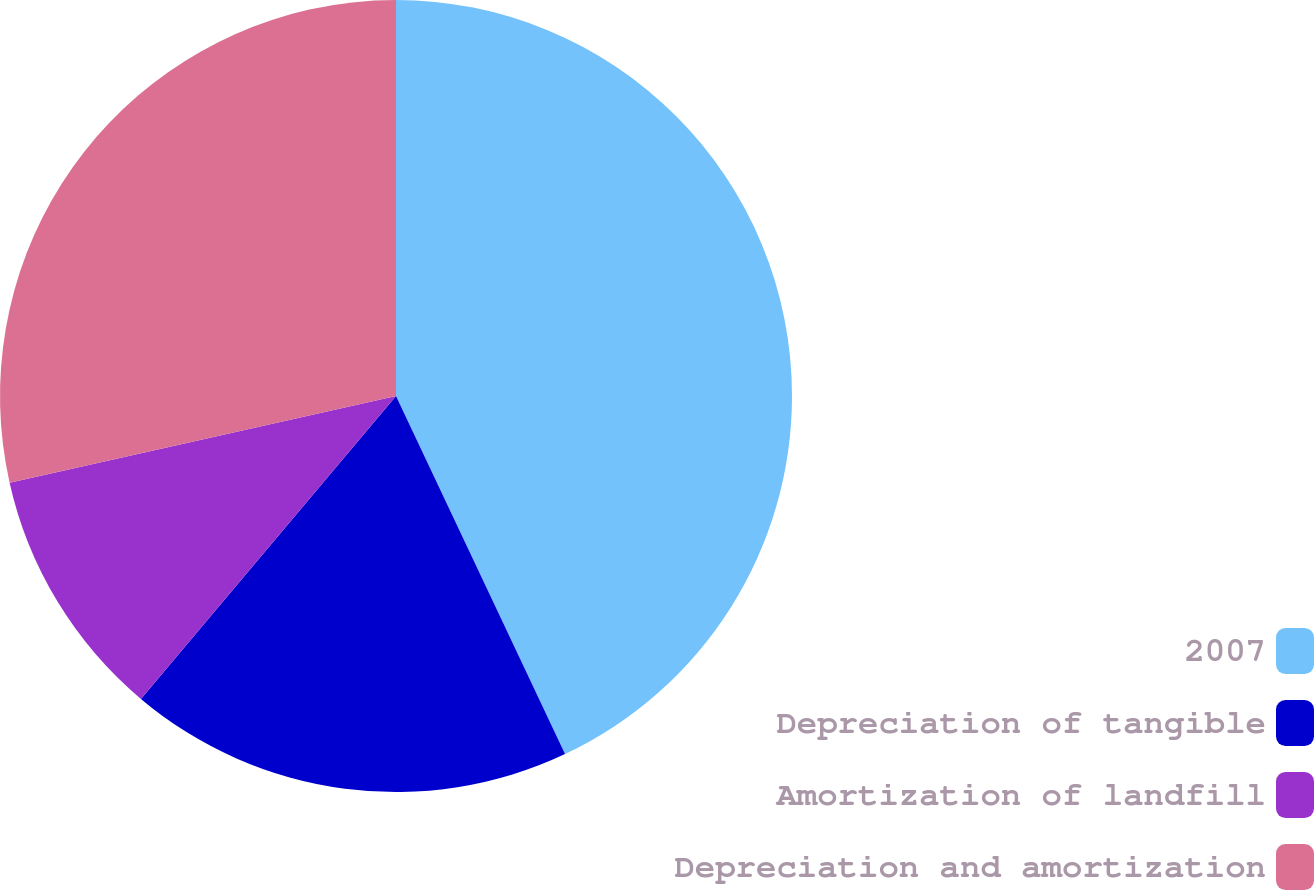<chart> <loc_0><loc_0><loc_500><loc_500><pie_chart><fcel>2007<fcel>Depreciation of tangible<fcel>Amortization of landfill<fcel>Depreciation and amortization<nl><fcel>42.98%<fcel>18.16%<fcel>10.35%<fcel>28.51%<nl></chart> 